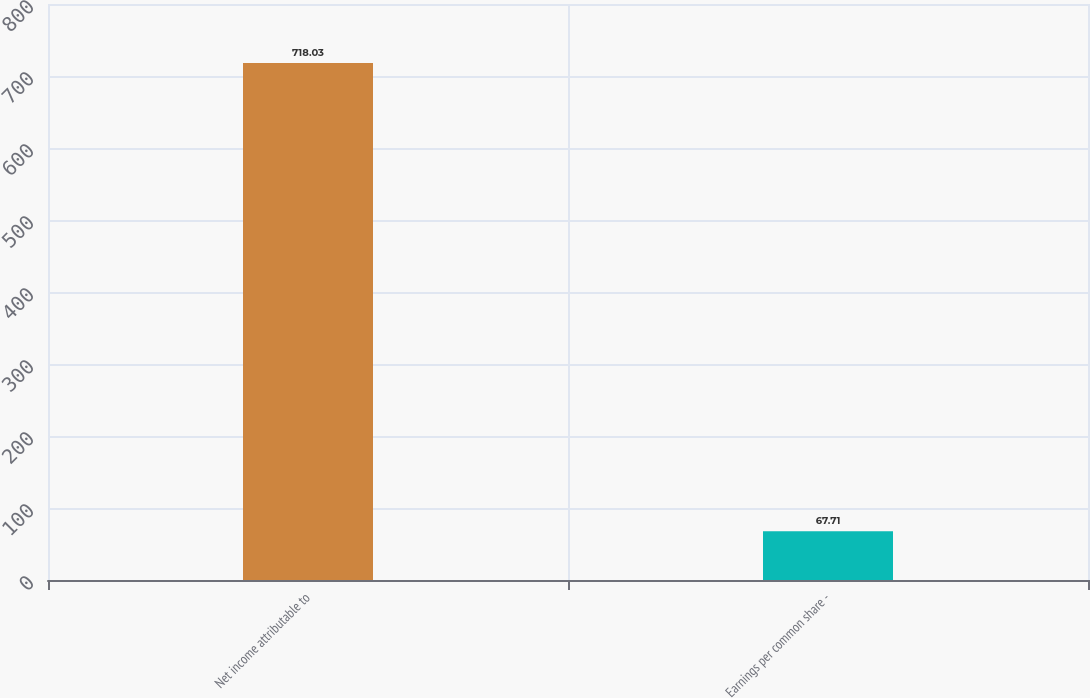Convert chart. <chart><loc_0><loc_0><loc_500><loc_500><bar_chart><fcel>Net income attributable to<fcel>Earnings per common share -<nl><fcel>718.03<fcel>67.71<nl></chart> 